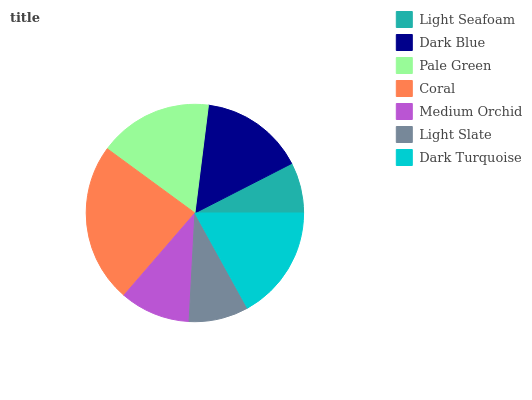Is Light Seafoam the minimum?
Answer yes or no. Yes. Is Coral the maximum?
Answer yes or no. Yes. Is Dark Blue the minimum?
Answer yes or no. No. Is Dark Blue the maximum?
Answer yes or no. No. Is Dark Blue greater than Light Seafoam?
Answer yes or no. Yes. Is Light Seafoam less than Dark Blue?
Answer yes or no. Yes. Is Light Seafoam greater than Dark Blue?
Answer yes or no. No. Is Dark Blue less than Light Seafoam?
Answer yes or no. No. Is Dark Blue the high median?
Answer yes or no. Yes. Is Dark Blue the low median?
Answer yes or no. Yes. Is Pale Green the high median?
Answer yes or no. No. Is Dark Turquoise the low median?
Answer yes or no. No. 